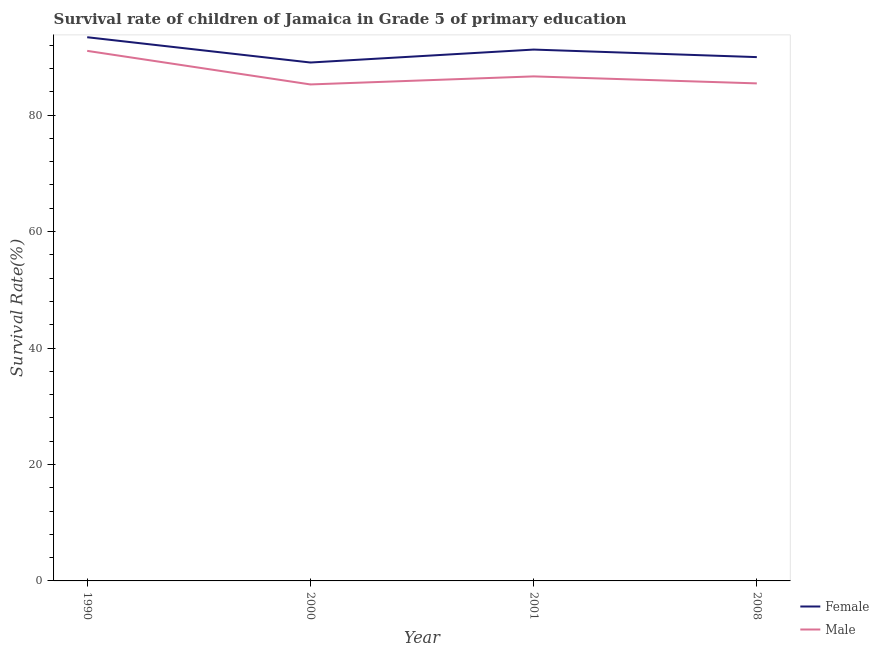Does the line corresponding to survival rate of female students in primary education intersect with the line corresponding to survival rate of male students in primary education?
Your response must be concise. No. Is the number of lines equal to the number of legend labels?
Make the answer very short. Yes. What is the survival rate of female students in primary education in 2000?
Provide a succinct answer. 89.03. Across all years, what is the maximum survival rate of female students in primary education?
Keep it short and to the point. 93.37. Across all years, what is the minimum survival rate of male students in primary education?
Your response must be concise. 85.26. What is the total survival rate of female students in primary education in the graph?
Your answer should be very brief. 363.6. What is the difference between the survival rate of male students in primary education in 1990 and that in 2008?
Provide a short and direct response. 5.59. What is the difference between the survival rate of female students in primary education in 1990 and the survival rate of male students in primary education in 2008?
Offer a very short reply. 7.93. What is the average survival rate of male students in primary education per year?
Your answer should be compact. 87.09. In the year 2001, what is the difference between the survival rate of female students in primary education and survival rate of male students in primary education?
Offer a terse response. 4.61. What is the ratio of the survival rate of female students in primary education in 2000 to that in 2001?
Keep it short and to the point. 0.98. Is the survival rate of male students in primary education in 2001 less than that in 2008?
Make the answer very short. No. Is the difference between the survival rate of male students in primary education in 2000 and 2001 greater than the difference between the survival rate of female students in primary education in 2000 and 2001?
Provide a succinct answer. Yes. What is the difference between the highest and the second highest survival rate of female students in primary education?
Make the answer very short. 2.12. What is the difference between the highest and the lowest survival rate of male students in primary education?
Offer a terse response. 5.77. Does the survival rate of female students in primary education monotonically increase over the years?
Provide a short and direct response. No. Is the survival rate of female students in primary education strictly greater than the survival rate of male students in primary education over the years?
Provide a short and direct response. Yes. Is the survival rate of female students in primary education strictly less than the survival rate of male students in primary education over the years?
Give a very brief answer. No. How many lines are there?
Provide a short and direct response. 2. What is the difference between two consecutive major ticks on the Y-axis?
Your answer should be very brief. 20. Does the graph contain any zero values?
Your answer should be compact. No. Does the graph contain grids?
Offer a very short reply. No. Where does the legend appear in the graph?
Offer a terse response. Bottom right. How many legend labels are there?
Give a very brief answer. 2. What is the title of the graph?
Your answer should be compact. Survival rate of children of Jamaica in Grade 5 of primary education. Does "Lower secondary rate" appear as one of the legend labels in the graph?
Provide a short and direct response. No. What is the label or title of the Y-axis?
Provide a short and direct response. Survival Rate(%). What is the Survival Rate(%) in Female in 1990?
Offer a terse response. 93.37. What is the Survival Rate(%) in Male in 1990?
Your response must be concise. 91.03. What is the Survival Rate(%) of Female in 2000?
Make the answer very short. 89.03. What is the Survival Rate(%) in Male in 2000?
Your answer should be compact. 85.26. What is the Survival Rate(%) of Female in 2001?
Your answer should be compact. 91.25. What is the Survival Rate(%) of Male in 2001?
Your response must be concise. 86.64. What is the Survival Rate(%) in Female in 2008?
Give a very brief answer. 89.95. What is the Survival Rate(%) of Male in 2008?
Provide a short and direct response. 85.44. Across all years, what is the maximum Survival Rate(%) in Female?
Your answer should be compact. 93.37. Across all years, what is the maximum Survival Rate(%) in Male?
Your answer should be compact. 91.03. Across all years, what is the minimum Survival Rate(%) in Female?
Provide a short and direct response. 89.03. Across all years, what is the minimum Survival Rate(%) in Male?
Your answer should be very brief. 85.26. What is the total Survival Rate(%) in Female in the graph?
Offer a terse response. 363.6. What is the total Survival Rate(%) of Male in the graph?
Offer a very short reply. 348.38. What is the difference between the Survival Rate(%) of Female in 1990 and that in 2000?
Your answer should be very brief. 4.34. What is the difference between the Survival Rate(%) of Male in 1990 and that in 2000?
Your answer should be very brief. 5.77. What is the difference between the Survival Rate(%) of Female in 1990 and that in 2001?
Offer a very short reply. 2.12. What is the difference between the Survival Rate(%) in Male in 1990 and that in 2001?
Offer a very short reply. 4.38. What is the difference between the Survival Rate(%) of Female in 1990 and that in 2008?
Make the answer very short. 3.41. What is the difference between the Survival Rate(%) of Male in 1990 and that in 2008?
Make the answer very short. 5.58. What is the difference between the Survival Rate(%) of Female in 2000 and that in 2001?
Your answer should be compact. -2.22. What is the difference between the Survival Rate(%) in Male in 2000 and that in 2001?
Keep it short and to the point. -1.38. What is the difference between the Survival Rate(%) of Female in 2000 and that in 2008?
Provide a short and direct response. -0.93. What is the difference between the Survival Rate(%) of Male in 2000 and that in 2008?
Provide a short and direct response. -0.18. What is the difference between the Survival Rate(%) in Female in 2001 and that in 2008?
Offer a very short reply. 1.3. What is the difference between the Survival Rate(%) of Male in 2001 and that in 2008?
Keep it short and to the point. 1.2. What is the difference between the Survival Rate(%) in Female in 1990 and the Survival Rate(%) in Male in 2000?
Make the answer very short. 8.11. What is the difference between the Survival Rate(%) in Female in 1990 and the Survival Rate(%) in Male in 2001?
Offer a very short reply. 6.72. What is the difference between the Survival Rate(%) of Female in 1990 and the Survival Rate(%) of Male in 2008?
Your response must be concise. 7.93. What is the difference between the Survival Rate(%) of Female in 2000 and the Survival Rate(%) of Male in 2001?
Make the answer very short. 2.38. What is the difference between the Survival Rate(%) of Female in 2000 and the Survival Rate(%) of Male in 2008?
Your answer should be very brief. 3.59. What is the difference between the Survival Rate(%) of Female in 2001 and the Survival Rate(%) of Male in 2008?
Your response must be concise. 5.81. What is the average Survival Rate(%) of Female per year?
Offer a terse response. 90.9. What is the average Survival Rate(%) of Male per year?
Give a very brief answer. 87.09. In the year 1990, what is the difference between the Survival Rate(%) of Female and Survival Rate(%) of Male?
Provide a succinct answer. 2.34. In the year 2000, what is the difference between the Survival Rate(%) in Female and Survival Rate(%) in Male?
Offer a terse response. 3.77. In the year 2001, what is the difference between the Survival Rate(%) of Female and Survival Rate(%) of Male?
Your response must be concise. 4.61. In the year 2008, what is the difference between the Survival Rate(%) of Female and Survival Rate(%) of Male?
Provide a short and direct response. 4.51. What is the ratio of the Survival Rate(%) in Female in 1990 to that in 2000?
Provide a succinct answer. 1.05. What is the ratio of the Survival Rate(%) in Male in 1990 to that in 2000?
Offer a very short reply. 1.07. What is the ratio of the Survival Rate(%) of Female in 1990 to that in 2001?
Provide a succinct answer. 1.02. What is the ratio of the Survival Rate(%) of Male in 1990 to that in 2001?
Your response must be concise. 1.05. What is the ratio of the Survival Rate(%) of Female in 1990 to that in 2008?
Make the answer very short. 1.04. What is the ratio of the Survival Rate(%) in Male in 1990 to that in 2008?
Your answer should be compact. 1.07. What is the ratio of the Survival Rate(%) in Female in 2000 to that in 2001?
Your answer should be compact. 0.98. What is the ratio of the Survival Rate(%) of Female in 2000 to that in 2008?
Your answer should be compact. 0.99. What is the ratio of the Survival Rate(%) in Male in 2000 to that in 2008?
Offer a terse response. 1. What is the ratio of the Survival Rate(%) of Female in 2001 to that in 2008?
Provide a short and direct response. 1.01. What is the ratio of the Survival Rate(%) of Male in 2001 to that in 2008?
Your answer should be compact. 1.01. What is the difference between the highest and the second highest Survival Rate(%) in Female?
Offer a terse response. 2.12. What is the difference between the highest and the second highest Survival Rate(%) in Male?
Offer a very short reply. 4.38. What is the difference between the highest and the lowest Survival Rate(%) of Female?
Ensure brevity in your answer.  4.34. What is the difference between the highest and the lowest Survival Rate(%) in Male?
Provide a succinct answer. 5.77. 